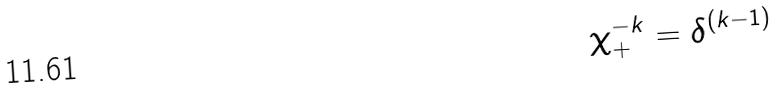Convert formula to latex. <formula><loc_0><loc_0><loc_500><loc_500>\chi _ { + } ^ { - k } = \delta ^ { ( k - 1 ) }</formula> 